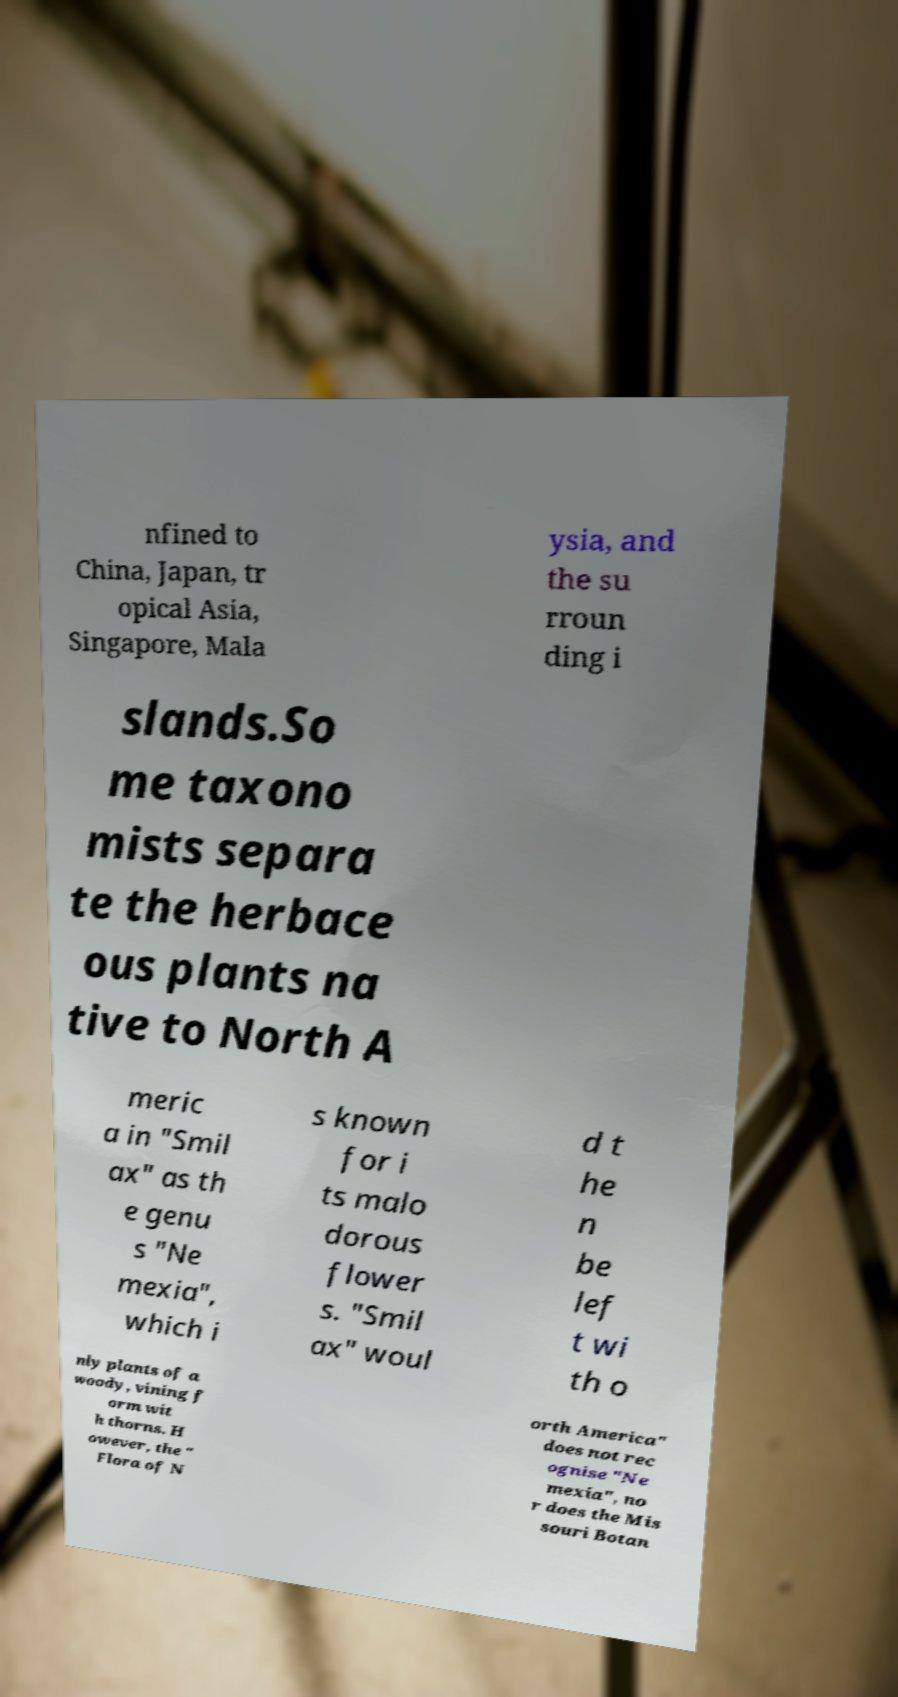Please read and relay the text visible in this image. What does it say? nfined to China, Japan, tr opical Asia, Singapore, Mala ysia, and the su rroun ding i slands.So me taxono mists separa te the herbace ous plants na tive to North A meric a in "Smil ax" as th e genu s "Ne mexia", which i s known for i ts malo dorous flower s. "Smil ax" woul d t he n be lef t wi th o nly plants of a woody, vining f orm wit h thorns. H owever, the " Flora of N orth America" does not rec ognise "Ne mexia", no r does the Mis souri Botan 